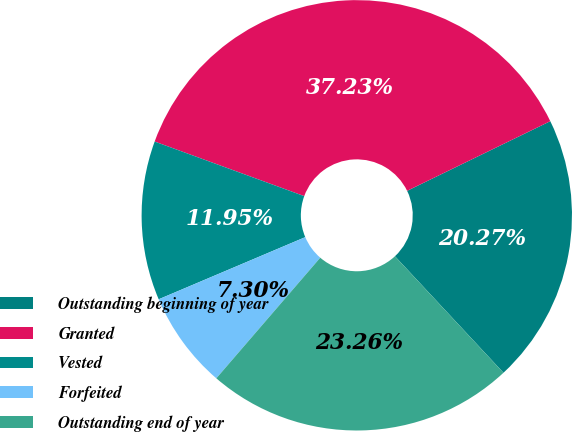Convert chart. <chart><loc_0><loc_0><loc_500><loc_500><pie_chart><fcel>Outstanding beginning of year<fcel>Granted<fcel>Vested<fcel>Forfeited<fcel>Outstanding end of year<nl><fcel>20.27%<fcel>37.23%<fcel>11.95%<fcel>7.3%<fcel>23.26%<nl></chart> 